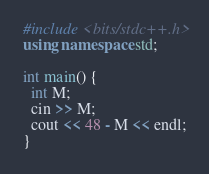<code> <loc_0><loc_0><loc_500><loc_500><_C++_>#include <bits/stdc++.h>
using namespace std;

int main() {
  int M;
  cin >> M;
  cout << 48 - M << endl;
}</code> 